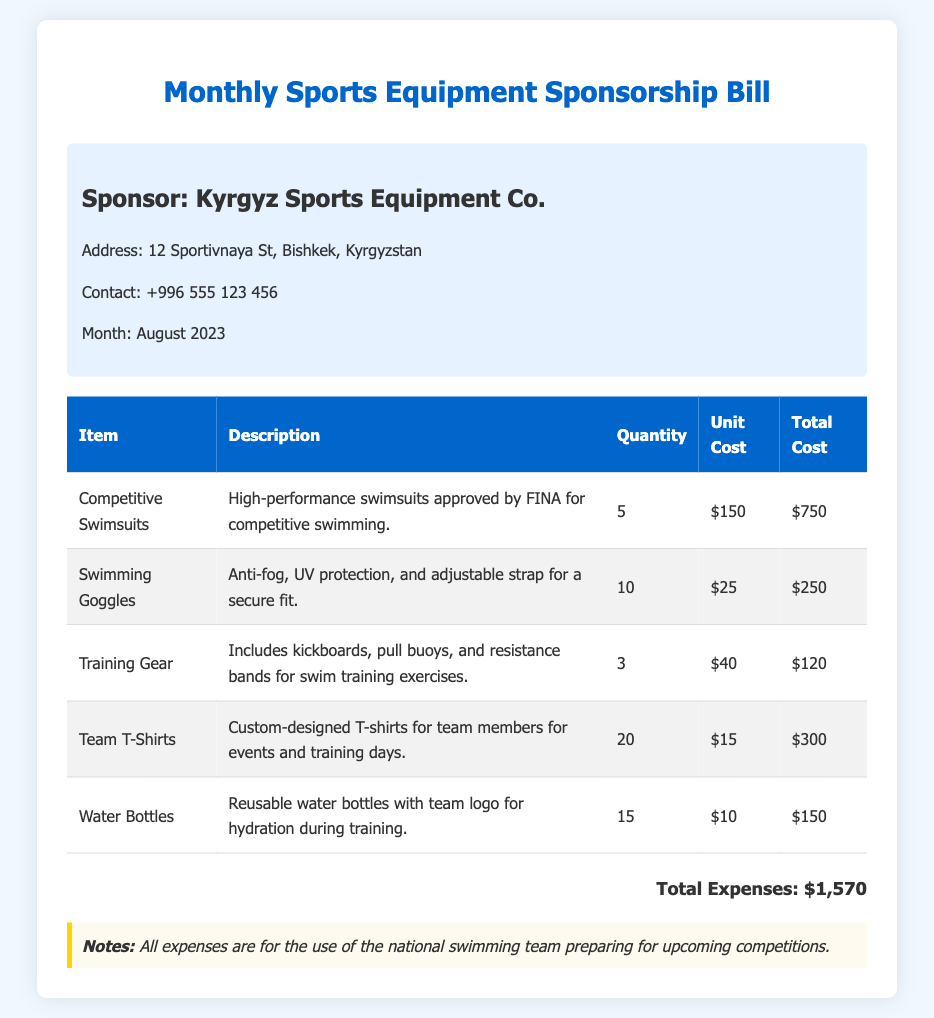What is the name of the sponsor? The sponsor's name is stated at the beginning of the document.
Answer: Kyrgyz Sports Equipment Co What is the address of the sponsor? The address is specified in the sponsor information section.
Answer: 12 Sportivnaya St, Bishkek, Kyrgyzstan What month does the bill cover? The month is indicated in the sponsor information section of the document.
Answer: August 2023 How many swimming goggles were purchased? This information can be found in the item list and is part of the quantity for swimming goggles.
Answer: 10 What is the total expense for competitive swimsuits? The total cost can be calculated from the respective line in the expense table.
Answer: $750 How many items are listed in the table? The number of items can be counted from the rows in the expense table.
Answer: 5 What is the unit cost of training gear? The unit cost of training gear is provided in the expense table.
Answer: $40 What is the total expense for the month? The total expenses for the items are summed at the bottom of the expense section.
Answer: $1,570 What purpose do the expenses serve according to the notes? The purpose is described in the notes section of the bill.
Answer: National swimming team preparation 